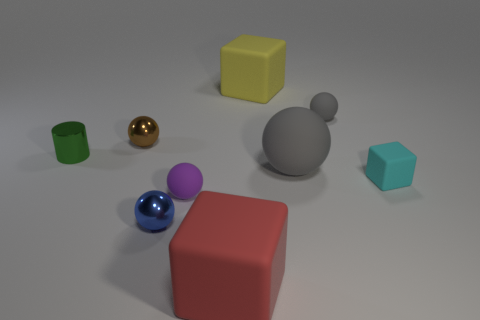Subtract 1 balls. How many balls are left? 4 Subtract all big rubber cubes. How many cubes are left? 1 Subtract all brown spheres. How many spheres are left? 4 Add 1 gray rubber objects. How many objects exist? 10 Subtract all purple balls. Subtract all red cubes. How many balls are left? 4 Subtract all balls. How many objects are left? 4 Subtract all tiny yellow cylinders. Subtract all big cubes. How many objects are left? 7 Add 3 small gray matte balls. How many small gray matte balls are left? 4 Add 9 big gray spheres. How many big gray spheres exist? 10 Subtract 1 yellow cubes. How many objects are left? 8 